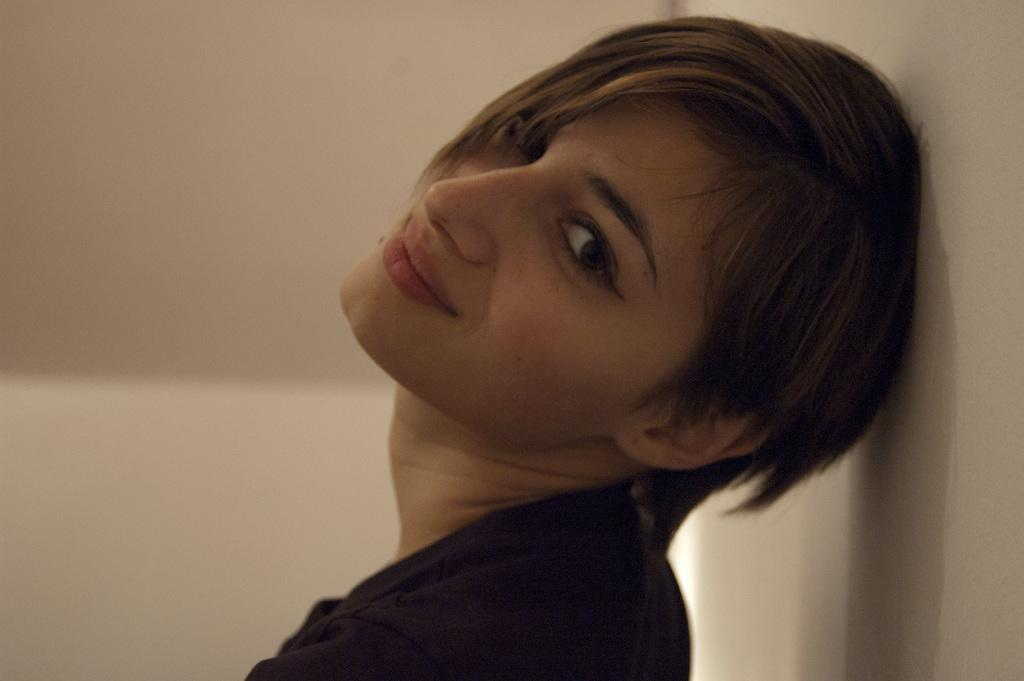Who or what is present in the image? There is a person in the image. What direction is the person facing? The person is facing towards the left side. What is the person's facial expression? The person is smiling. What is the person looking at? The person is looking at a picture. What can be seen on the right side of the image? There is a wall on the right side of the image. What type of song is being played in the background of the image? There is no information about any song being played in the image. 